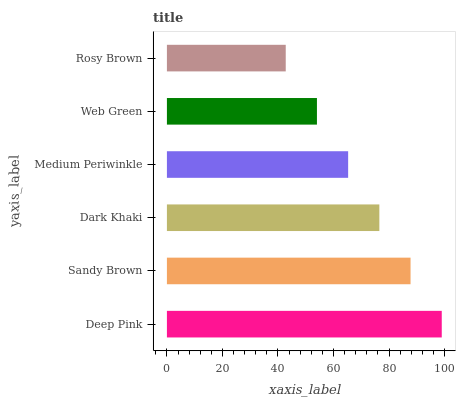Is Rosy Brown the minimum?
Answer yes or no. Yes. Is Deep Pink the maximum?
Answer yes or no. Yes. Is Sandy Brown the minimum?
Answer yes or no. No. Is Sandy Brown the maximum?
Answer yes or no. No. Is Deep Pink greater than Sandy Brown?
Answer yes or no. Yes. Is Sandy Brown less than Deep Pink?
Answer yes or no. Yes. Is Sandy Brown greater than Deep Pink?
Answer yes or no. No. Is Deep Pink less than Sandy Brown?
Answer yes or no. No. Is Dark Khaki the high median?
Answer yes or no. Yes. Is Medium Periwinkle the low median?
Answer yes or no. Yes. Is Deep Pink the high median?
Answer yes or no. No. Is Web Green the low median?
Answer yes or no. No. 